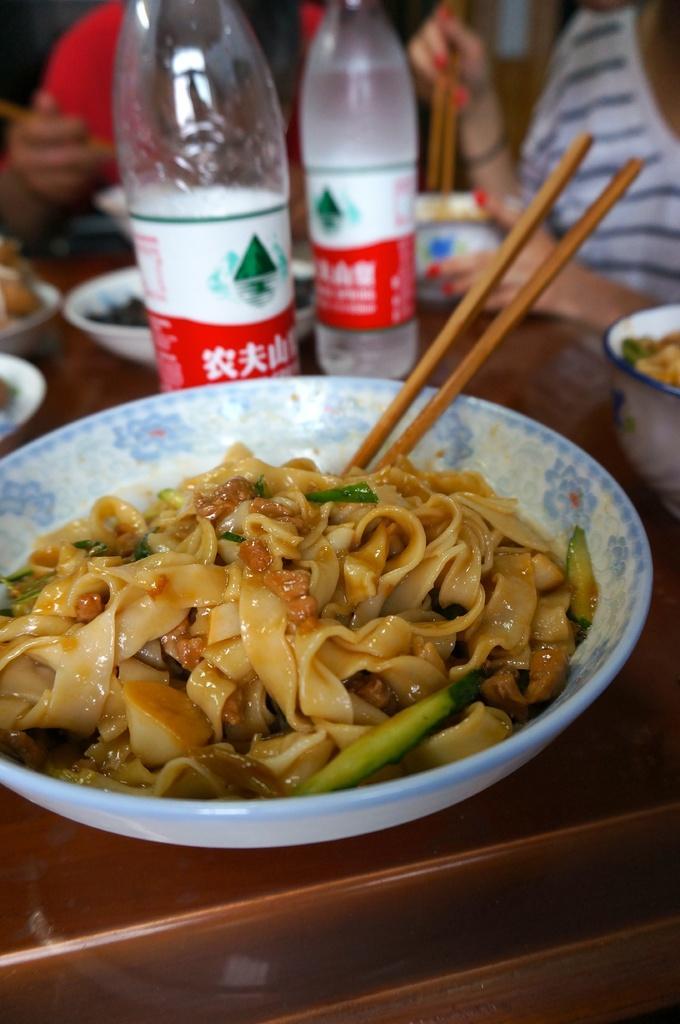Please provide a concise description of this image. In this image there is bowl of noodles with chopsticks on the table. On the table there are two bottles and some bowls and two persons are sitting beside it. 